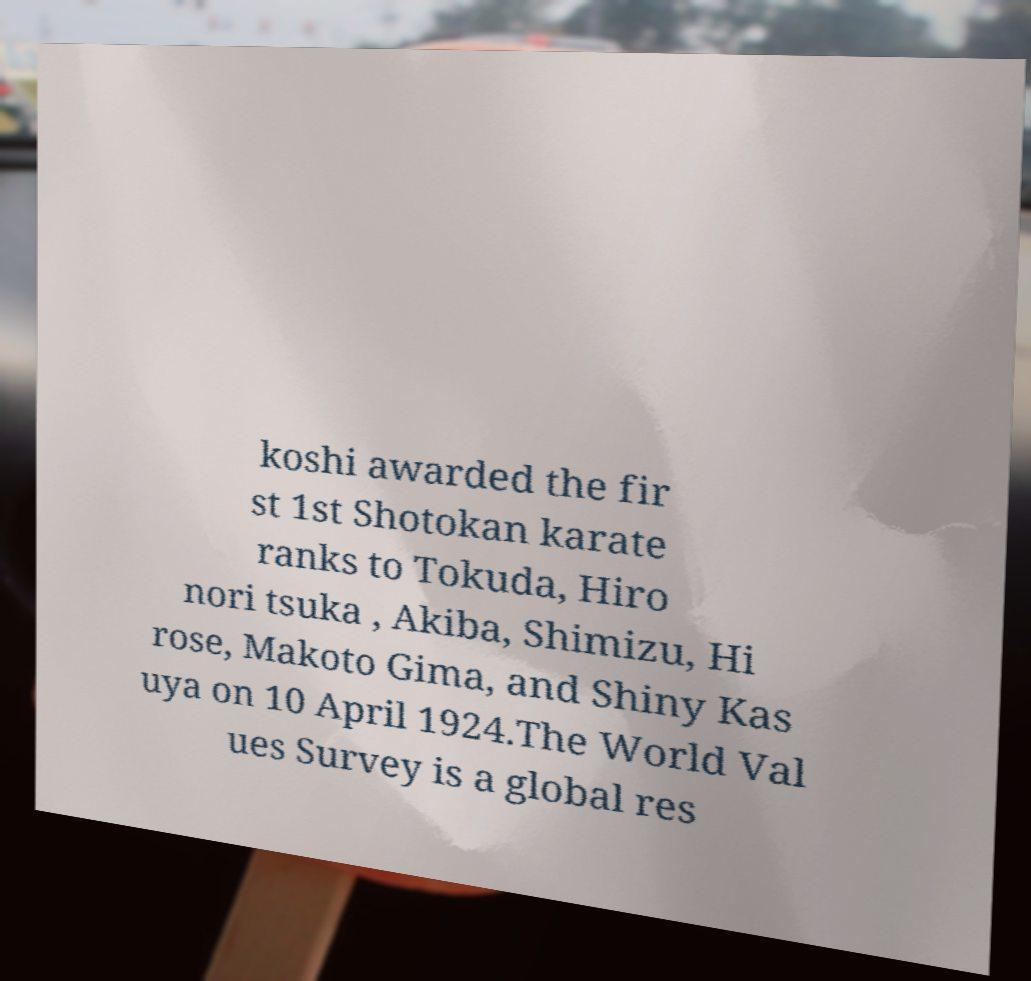Could you extract and type out the text from this image? koshi awarded the fir st 1st Shotokan karate ranks to Tokuda, Hiro nori tsuka , Akiba, Shimizu, Hi rose, Makoto Gima, and Shiny Kas uya on 10 April 1924.The World Val ues Survey is a global res 